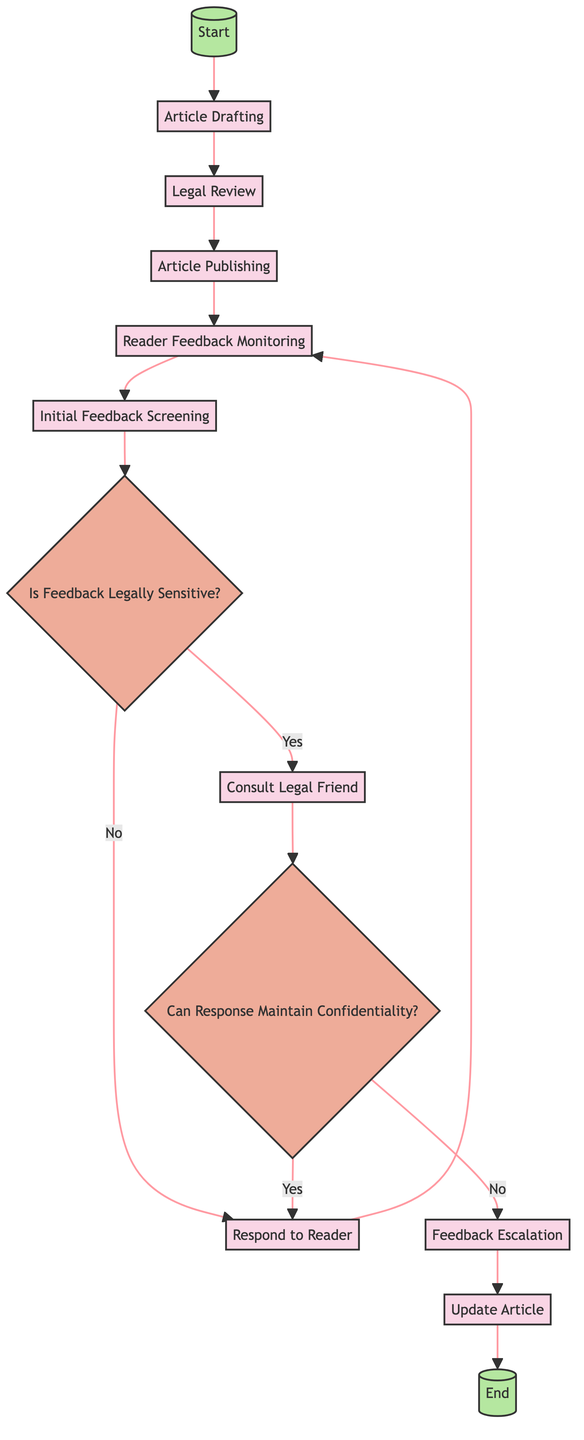What is the starting activity in the diagram? The starting activity is indicated at the beginning of the diagram in the node labeled "Article Drafting." This activity is the first step in the process.
Answer: Article Drafting How many activities are present in the diagram? By counting all the nodes classified as activities in the diagram, there are eight activities listed.
Answer: 8 What comes after “Legal Review”? Following "Legal Review," the next activity in the flow is "Article Publishing." The arrows connecting the nodes illustrate this progression.
Answer: Article Publishing What decision comes after “Initial Feedback Screening”? The decision that follows "Initial Feedback Screening" is "Is Feedback Legally Sensitive?" This can be identified by the directed flow leading from feedback screening to the decision node.
Answer: Is Feedback Legally Sensitive? What happens if the feedback is deemed legally sensitive? If feedback is identified as legally sensitive, the next step is to "Consult Legal Friend," as indicated by the 'Yes' path emerging from the decision node.
Answer: Consult Legal Friend How many decisions are there in the diagram? Upon reviewing the diagram, there are two distinct decision nodes indicated, confirming there are two decisions in total.
Answer: 2 What is the final activity in the diagram? The final activity is labeled "Update Article," which is where the process concludes before reaching the end node of the diagram.
Answer: Update Article What determines whether a public response can be made? The ability to make a public response is determined by the decision labeled "Can Response Maintain Confidentiality?" which assesses the confidentiality of the feedback.
Answer: Can Response Maintain Confidentiality? Which activity occurs before "Feedback Escalation"? The activity that occurs directly before "Feedback Escalation" is "Consult Legal Friend," based on the sequential flow presented in the diagram.
Answer: Consult Legal Friend 